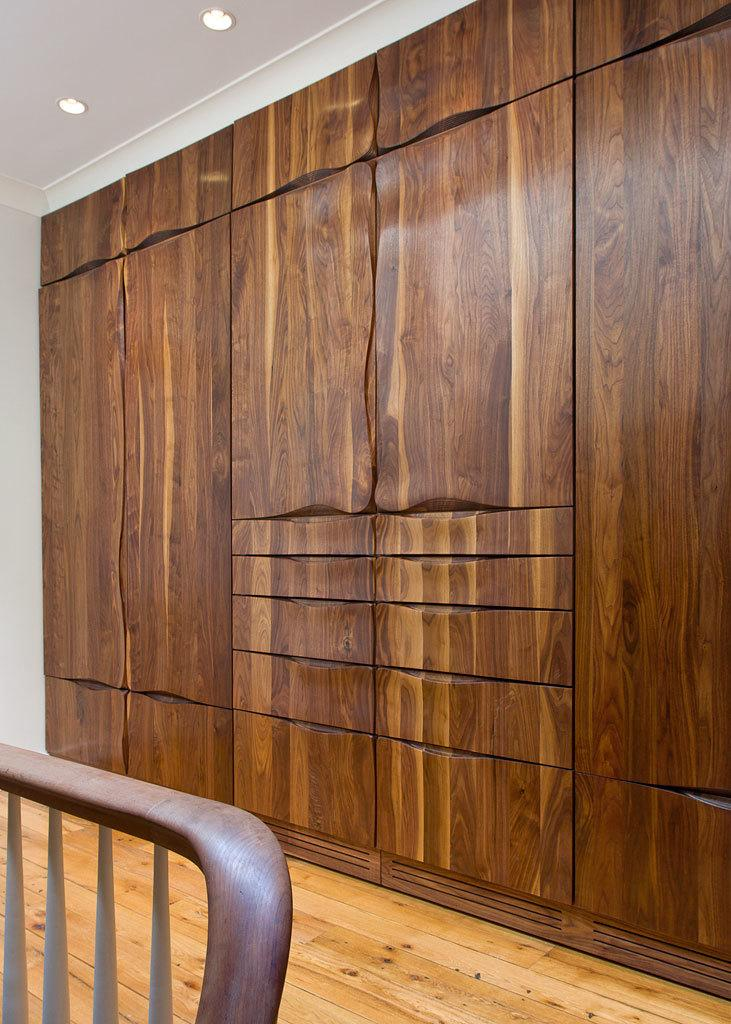What type of flooring is visible in the image? There is a wooden floor in the image. What piece of furniture is on the wooden floor? There is a chair on the wooden floor. What type of storage units are visible behind the chair? There are wooden cupboards behind the chair. What type of lighting is present in the image? Ceiling lights are present in the image. Where is the father sitting with the kitty in the image? There is no father or kitty present in the image. 